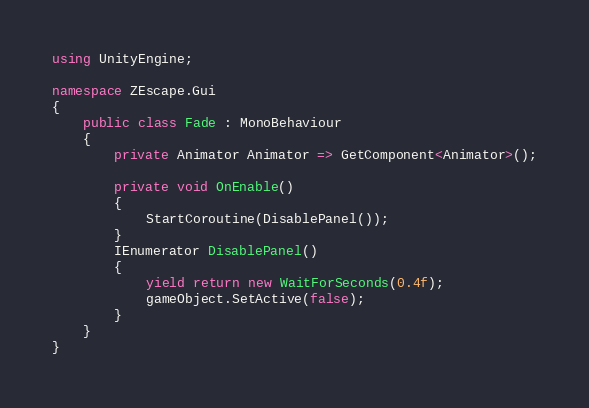Convert code to text. <code><loc_0><loc_0><loc_500><loc_500><_C#_>using UnityEngine;

namespace ZEscape.Gui
{
    public class Fade : MonoBehaviour
    {
        private Animator Animator => GetComponent<Animator>();

        private void OnEnable()
        {
            StartCoroutine(DisablePanel());
        }
        IEnumerator DisablePanel()
        {
            yield return new WaitForSeconds(0.4f);
            gameObject.SetActive(false);
        }
    }
}</code> 